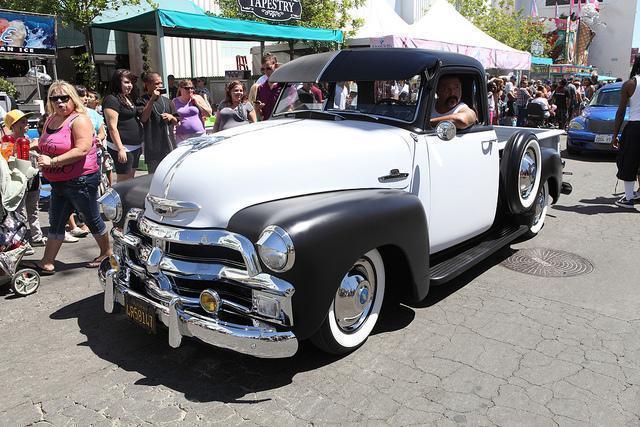Where Tapestry is located?
Select the correct answer and articulate reasoning with the following format: 'Answer: answer
Rationale: rationale.'
Options: California, london, none, new york. Answer: new york.
Rationale: Its located in london because most vintage cars are in london. 